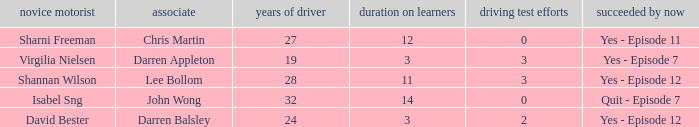Among drivers older than 24, who has taken the license test more than 0 times? Shannan Wilson. 